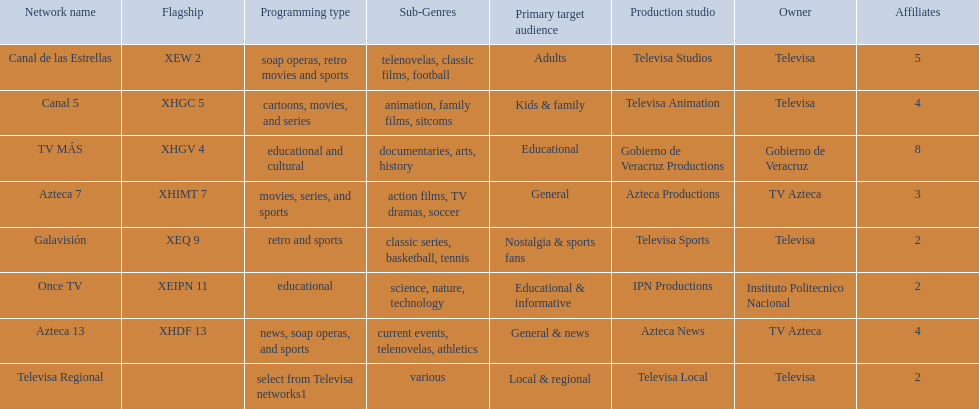Help me parse the entirety of this table. {'header': ['Network name', 'Flagship', 'Programming type', 'Sub-Genres', 'Primary target audience', 'Production studio', 'Owner', 'Affiliates'], 'rows': [['Canal de las Estrellas', 'XEW 2', 'soap operas, retro movies and sports', 'telenovelas, classic films, football', 'Adults', 'Televisa Studios', 'Televisa', '5'], ['Canal 5', 'XHGC 5', 'cartoons, movies, and series', 'animation, family films, sitcoms', 'Kids & family', 'Televisa Animation', 'Televisa', '4'], ['TV MÁS', 'XHGV 4', 'educational and cultural', 'documentaries, arts, history', 'Educational', 'Gobierno de Veracruz Productions', 'Gobierno de Veracruz', '8'], ['Azteca 7', 'XHIMT 7', 'movies, series, and sports', 'action films, TV dramas, soccer', 'General', 'Azteca Productions', 'TV Azteca', '3'], ['Galavisión', 'XEQ 9', 'retro and sports', 'classic series, basketball, tennis', 'Nostalgia & sports fans', 'Televisa Sports', 'Televisa', '2'], ['Once TV', 'XEIPN 11', 'educational', 'science, nature, technology', 'Educational & informative', 'IPN Productions', 'Instituto Politecnico Nacional', '2'], ['Azteca 13', 'XHDF 13', 'news, soap operas, and sports', 'current events, telenovelas, athletics', 'General & news', 'Azteca News', 'TV Azteca', '4'], ['Televisa Regional', '', 'select from Televisa networks1', 'various', 'Local & regional', 'Televisa Local', 'Televisa', '2']]} How many networks show soap operas? 2. 